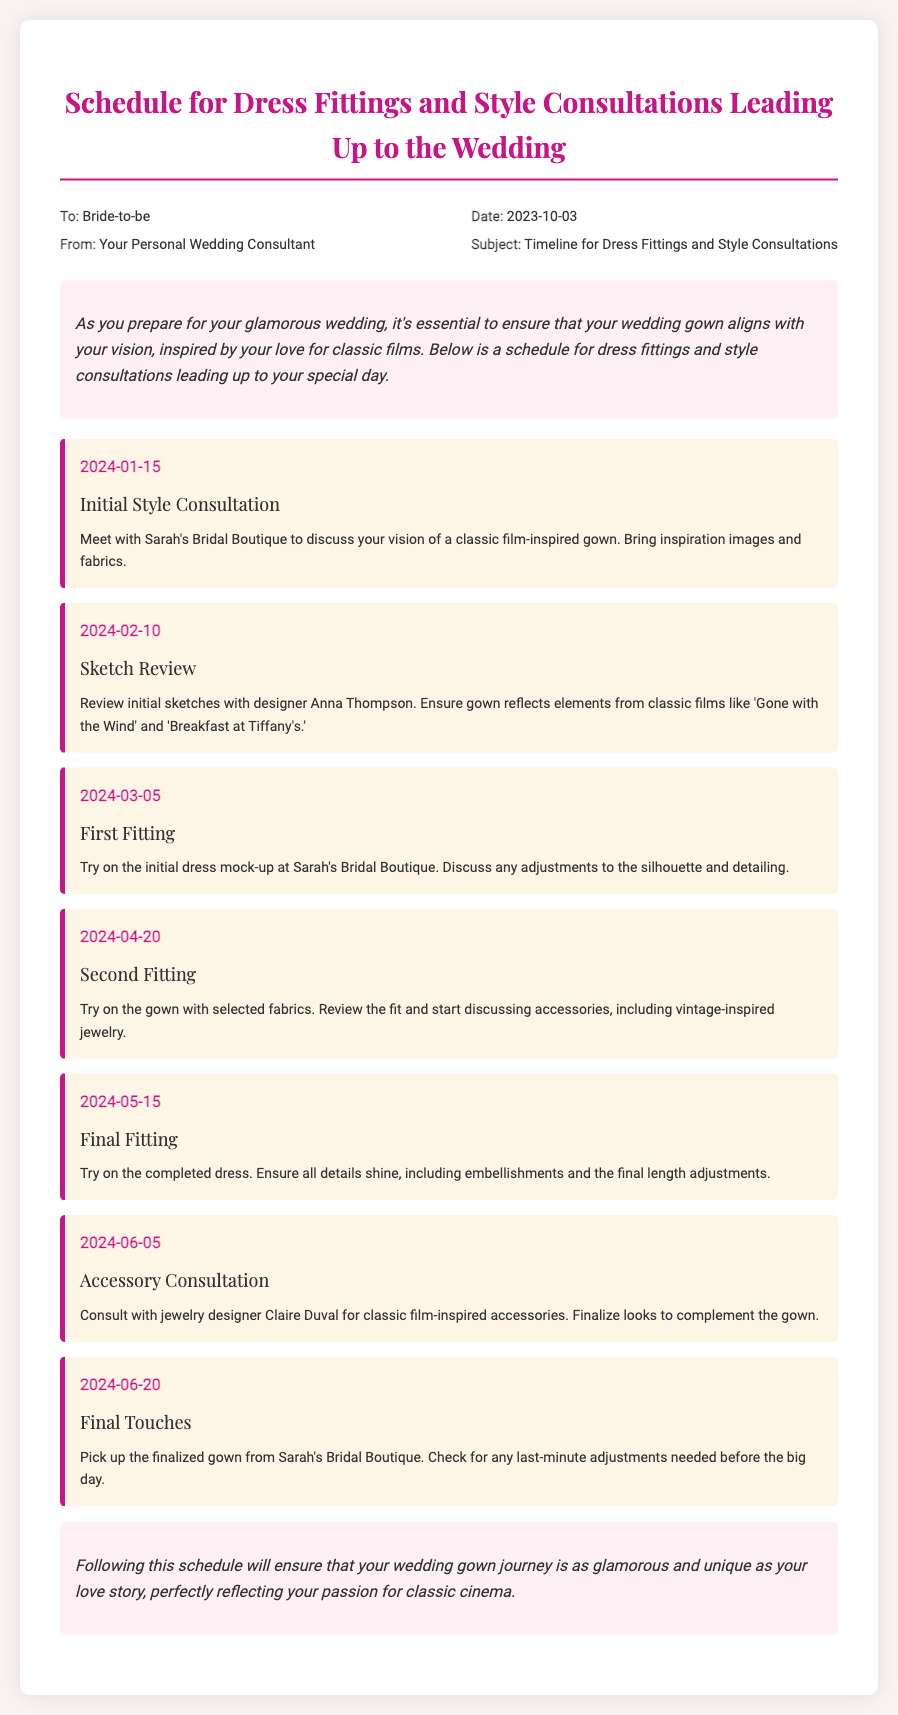what is the date of the initial style consultation? The document states that the initial style consultation is scheduled for January 15, 2024.
Answer: January 15, 2024 who is the designer for the sketch review? The document mentions the designer is Anna Thompson for the sketch review on February 10, 2024.
Answer: Anna Thompson when is the final fitting scheduled? According to the schedule, the final fitting is on May 15, 2024.
Answer: May 15, 2024 what is being discussed during the second fitting? The details indicate that during the second fitting, the gown's fit is reviewed, and accessories are discussed.
Answer: Accessories how many fittings are scheduled before the wedding? The memo includes a total of five fittings scheduled before the wedding.
Answer: Five what is the purpose of the accessory consultation? The purpose of the accessory consultation is to finalize looks to complement the gown with classic film-inspired accessories.
Answer: Finalize looks what is the emphasized theme for the wedding gown? The theme emphasized for the wedding gown is inspired by classic films.
Answer: Classic films who is the memo addressed to? The memo is addressed to the Bride-to-be.
Answer: Bride-to-be 